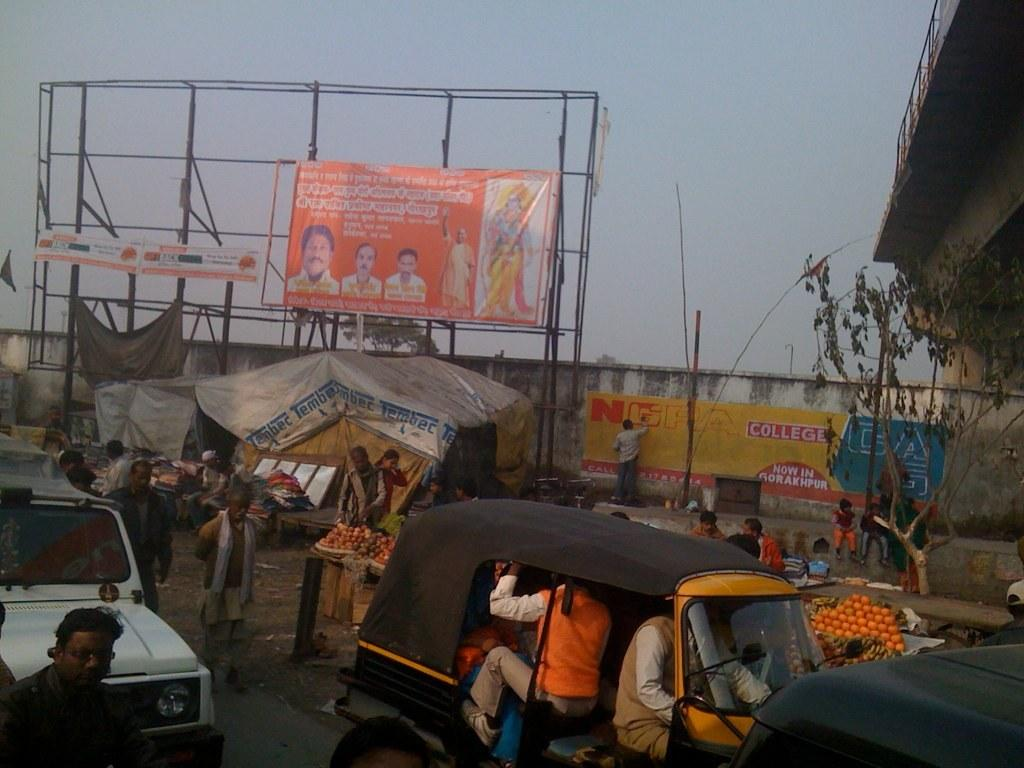Provide a one-sentence caption for the provided image. A man is painting in the word NCPA College, on a banner that is hung on a wall, on the side of a street. 